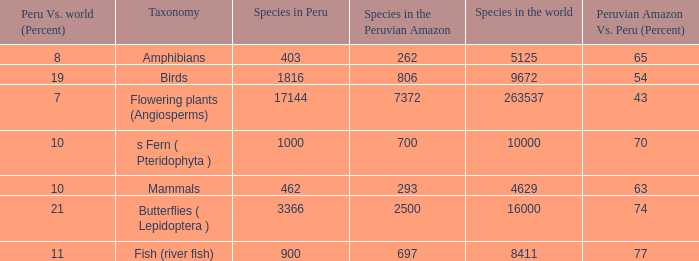What's the total number of species in the peruvian amazon with 8411 species in the world  1.0. 